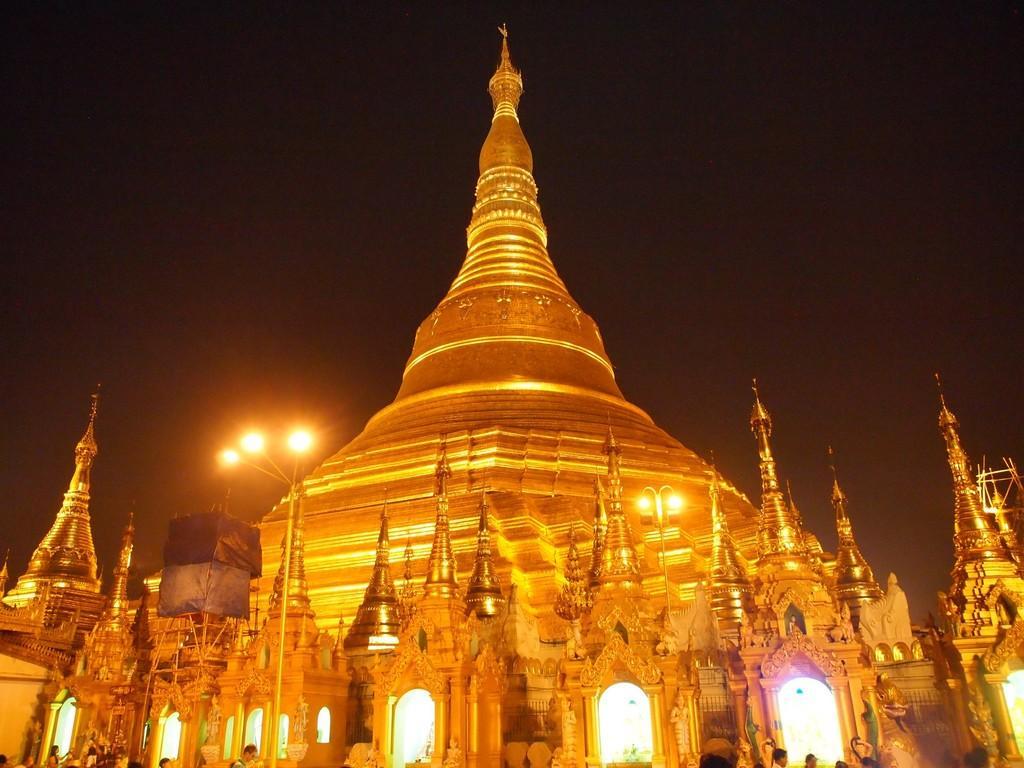Could you give a brief overview of what you see in this image? In this image there is a monument, in front of the monument there are a few people and lamp posts. 